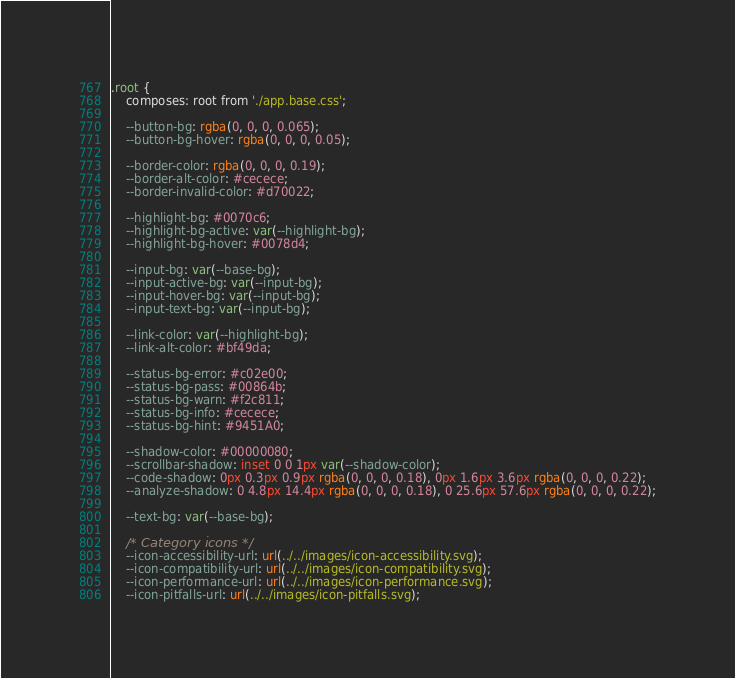<code> <loc_0><loc_0><loc_500><loc_500><_CSS_>.root {
    composes: root from './app.base.css';

    --button-bg: rgba(0, 0, 0, 0.065);
    --button-bg-hover: rgba(0, 0, 0, 0.05);

    --border-color: rgba(0, 0, 0, 0.19);
    --border-alt-color: #cecece;
    --border-invalid-color: #d70022;

    --highlight-bg: #0070c6;
    --highlight-bg-active: var(--highlight-bg);
    --highlight-bg-hover: #0078d4;

    --input-bg: var(--base-bg);
    --input-active-bg: var(--input-bg);
    --input-hover-bg: var(--input-bg);
    --input-text-bg: var(--input-bg);

    --link-color: var(--highlight-bg);
    --link-alt-color: #bf49da;

    --status-bg-error: #c02e00;
    --status-bg-pass: #00864b;
    --status-bg-warn: #f2c811;
    --status-bg-info: #cecece;
    --status-bg-hint: #9451A0;

    --shadow-color: #00000080;
    --scrollbar-shadow: inset 0 0 1px var(--shadow-color);
    --code-shadow: 0px 0.3px 0.9px rgba(0, 0, 0, 0.18), 0px 1.6px 3.6px rgba(0, 0, 0, 0.22);
    --analyze-shadow: 0 4.8px 14.4px rgba(0, 0, 0, 0.18), 0 25.6px 57.6px rgba(0, 0, 0, 0.22);

    --text-bg: var(--base-bg);

    /* Category icons */
    --icon-accessibility-url: url(../../images/icon-accessibility.svg);
    --icon-compatibility-url: url(../../images/icon-compatibility.svg);
    --icon-performance-url: url(../../images/icon-performance.svg);
    --icon-pitfalls-url: url(../../images/icon-pitfalls.svg);</code> 